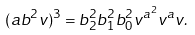<formula> <loc_0><loc_0><loc_500><loc_500>( a b ^ { 2 } v ) ^ { 3 } = b _ { 2 } ^ { 2 } b _ { 1 } ^ { 2 } b _ { 0 } ^ { 2 } v ^ { a ^ { 2 } } v ^ { a } v .</formula> 